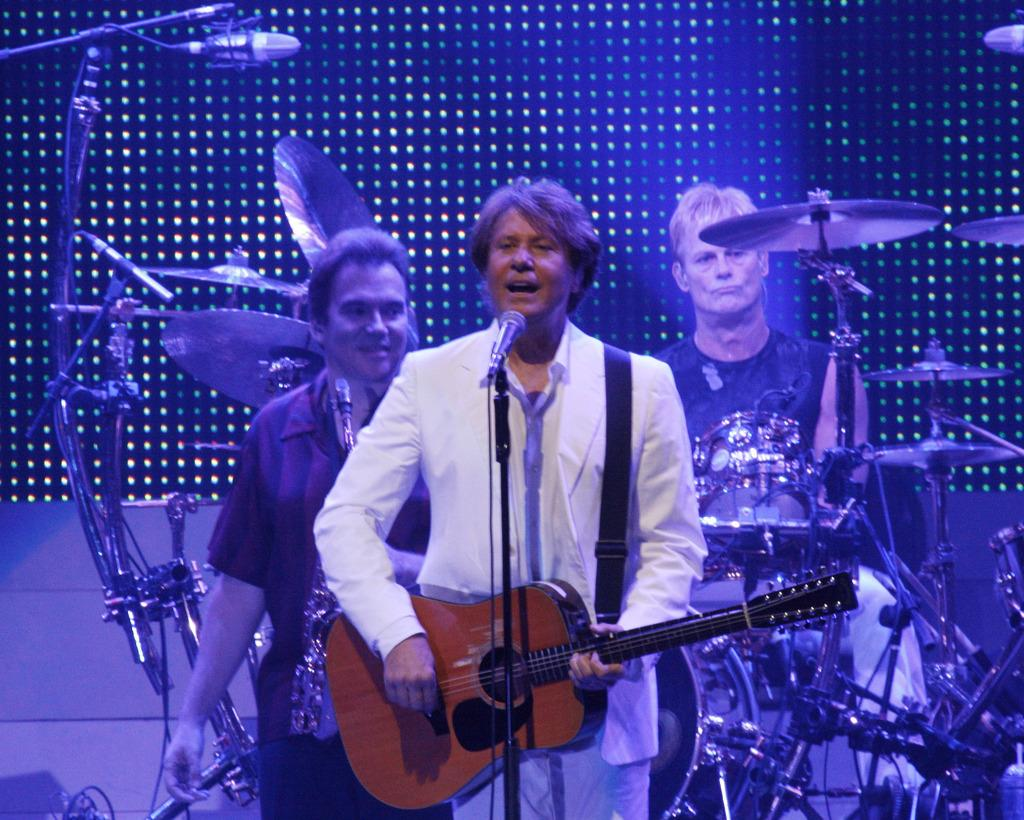How many people are present in the image? There are three people standing in the image. What is one person holding in the image? One person is holding a guitar. What else can be seen in the image related to music? There is a microphone and a microphone stand in the image. What type of eggnog is being served on the board in the image? There is no eggnog or board present in the image. 